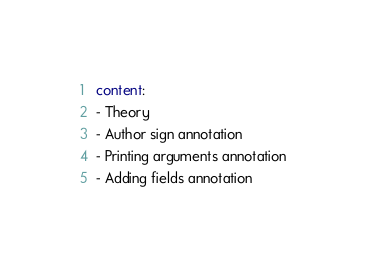<code> <loc_0><loc_0><loc_500><loc_500><_YAML_>content:
- Theory
- Author sign annotation
- Printing arguments annotation
- Adding fields annotation
</code> 